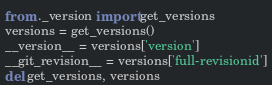Convert code to text. <code><loc_0><loc_0><loc_500><loc_500><_Python_>from ._version import get_versions
versions = get_versions()
__version__ = versions['version']
__git_revision__ = versions['full-revisionid']
del get_versions, versions
</code> 